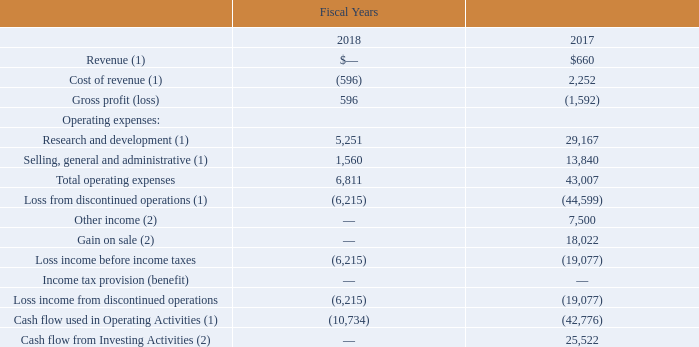Discontinued Operations
On October 27, 2017, we entered into a purchase agreement to sell the Compute business. In consideration for the transfer and sale of the Compute business, we received an equity interest in the buyer valued at approximately $36.5 million, representing the carrying value of the assets divested and representing less than 20.0% of the buyer's total outstanding equity. The operations of the Compute business were accounted for as discontinued operations through the date of divestiture.
We also entered into a transition services agreement (the "Compute TSA"), pursuant to which we agreed to perform certain primarily general and administrative functions on the buyer's behalf during a migration period and for which we are reimbursed for costs incurred.
During the fiscal year 2019, we received $0.1 million of reimbursements under the Compute TSA, which was recorded as a reduction of our general and administrative expenses. During the fiscal year 2018, we received $3.6 million of reimbursements under the Compute TSA, which was recorded as a reduction of our general and administrative expenses.
In August of fiscal year 2015, we sold our Automotive business, as the Automotive business was not consistent with our long-term strategic vision from both a growth and profitability perspective.
Additionally, we entered into a Consulting Agreement with the buyer pursuant to which we were to provide the buyer with certain non-design advisory services for a period of two years following the closing of the transaction for up to $15.0 million, from which we have recorded $7.5 million as other income during both fiscal years 2017 and 2016. No income was recognized during fiscal years 2019 or 2018. During fiscal year 2017, we received $18.0 million, the full amount of the indemnification escrow.
The accompanying Consolidated Statements of Operations includes the following operating results related to these discontinued operations (in thousands):
(1) Amounts are associated with the Compute business. (2) Amounts are associated with the Automotive business.
When did the company enter into purchase agreement to sell the Compute business? October 27, 2017. What was the Revenue in 2018 and 2017 respectively?
Answer scale should be: thousand. $—, $660. What was the amount of reimbursements under the Compute TSA in 2019? $0.1 million. In which year was Cost of revenue negative? Locate and analyze cost of revenue (1) in row 4
answer: 2018. What was the average Research and development for 2017 and 2018?
Answer scale should be: thousand. (5,251 + 29,167) / 2
Answer: 17209. What was the change in the Selling, general and administrative expense from 2017 to 2018?
Answer scale should be: thousand. 1,560 - 13,840
Answer: -12280. 